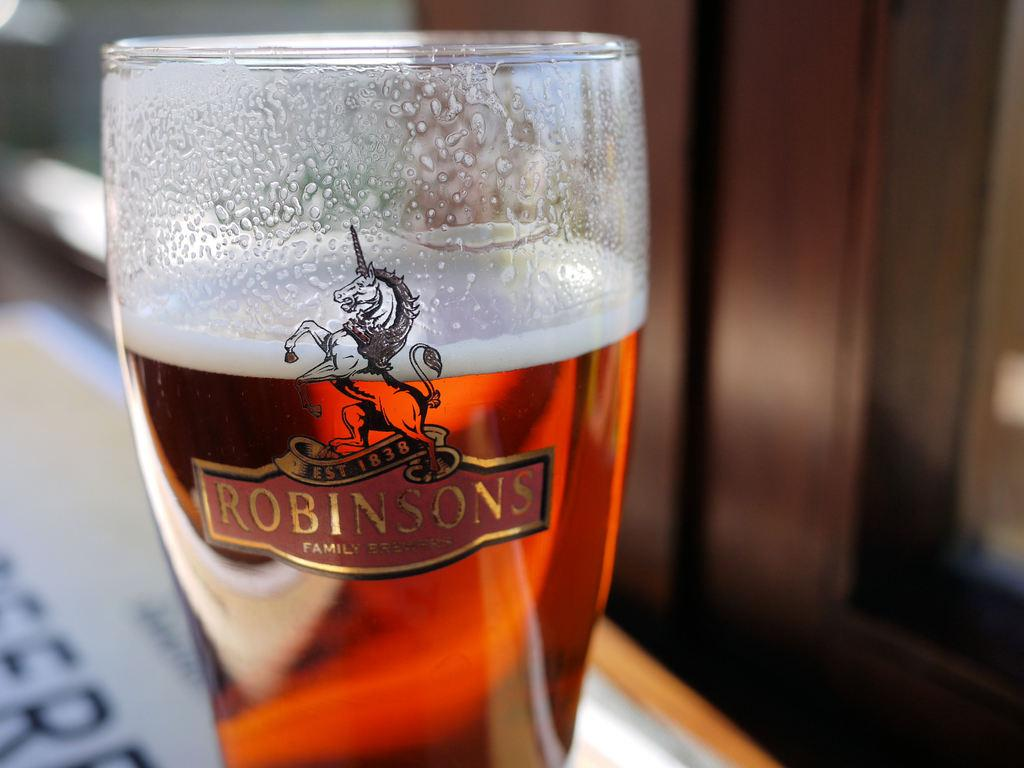<image>
Describe the image concisely. a glass full of liquid with the logo 'robinsons' on it 